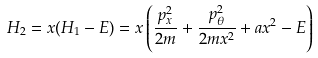<formula> <loc_0><loc_0><loc_500><loc_500>H _ { 2 } = x ( H _ { 1 } - E ) = x \left ( \frac { p ^ { 2 } _ { x } } { 2 m } + \frac { p ^ { 2 } _ { \theta } } { 2 m x ^ { 2 } } + a x ^ { 2 } - E \right )</formula> 